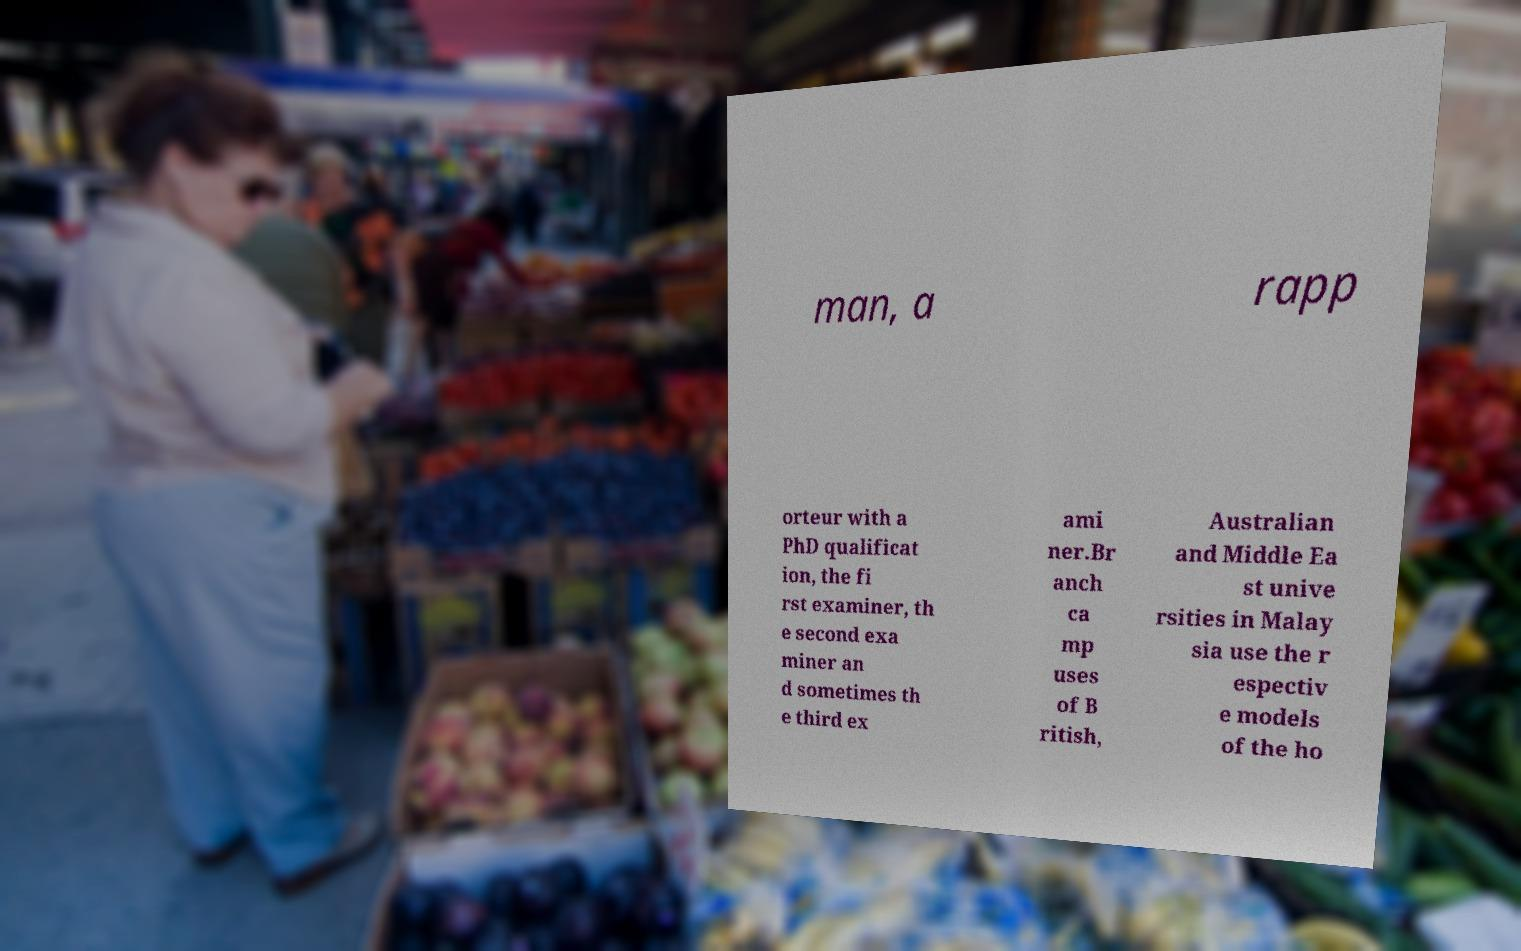Could you assist in decoding the text presented in this image and type it out clearly? man, a rapp orteur with a PhD qualificat ion, the fi rst examiner, th e second exa miner an d sometimes th e third ex ami ner.Br anch ca mp uses of B ritish, Australian and Middle Ea st unive rsities in Malay sia use the r espectiv e models of the ho 